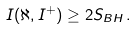Convert formula to latex. <formula><loc_0><loc_0><loc_500><loc_500>I ( \aleph , I ^ { + } ) \geq 2 S _ { B H } \, .</formula> 